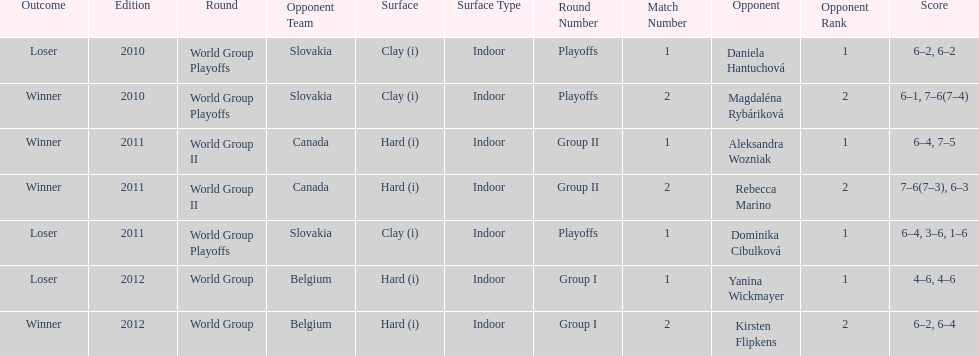Was the game versus canada later than the game versus belgium? No. 